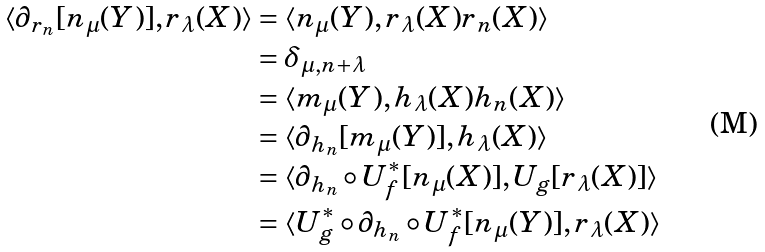<formula> <loc_0><loc_0><loc_500><loc_500>\langle \partial _ { r _ { n } } [ n _ { \mu } ( Y ) ] , r _ { \lambda } ( X ) \rangle & = \langle n _ { \mu } ( Y ) , r _ { \lambda } ( X ) r _ { n } ( X ) \rangle \\ & = \delta _ { \mu , n + \lambda } \\ & = \langle m _ { \mu } ( Y ) , h _ { \lambda } ( X ) h _ { n } ( X ) \rangle \\ & = \langle \partial _ { h _ { n } } [ m _ { \mu } ( Y ) ] , h _ { \lambda } ( X ) \rangle \\ & = \langle \partial _ { h _ { n } } \circ U ^ { * } _ { f } [ n _ { \mu } ( X ) ] , U _ { g } [ r _ { \lambda } ( X ) ] \rangle \\ & = \langle U ^ { * } _ { g } \circ \partial _ { h _ { n } } \circ U ^ { * } _ { f } [ n _ { \mu } ( Y ) ] , r _ { \lambda } ( X ) \rangle</formula> 